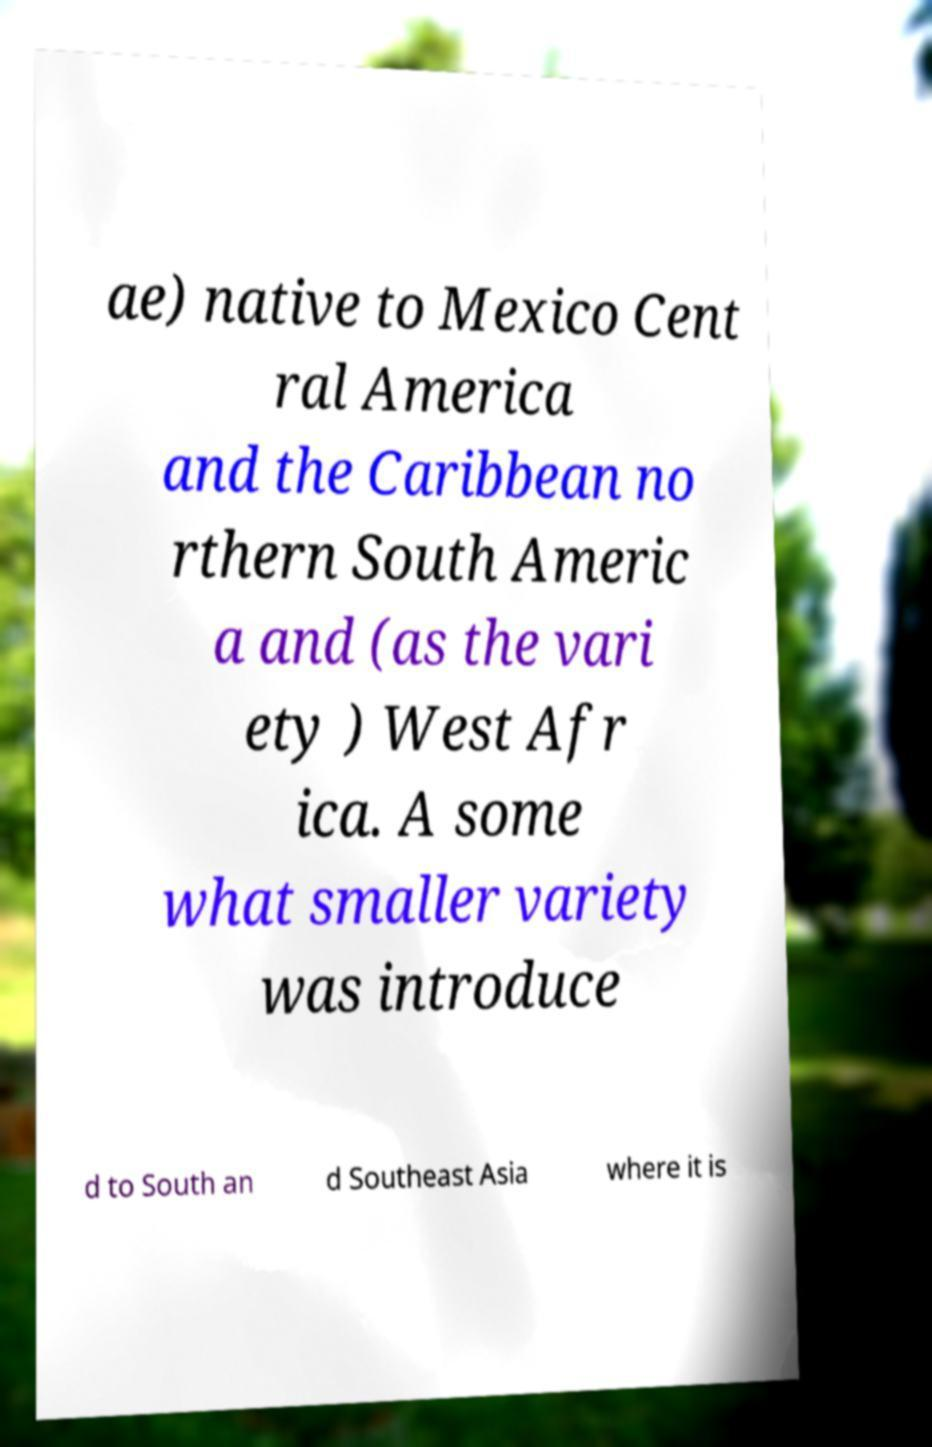There's text embedded in this image that I need extracted. Can you transcribe it verbatim? ae) native to Mexico Cent ral America and the Caribbean no rthern South Americ a and (as the vari ety ) West Afr ica. A some what smaller variety was introduce d to South an d Southeast Asia where it is 